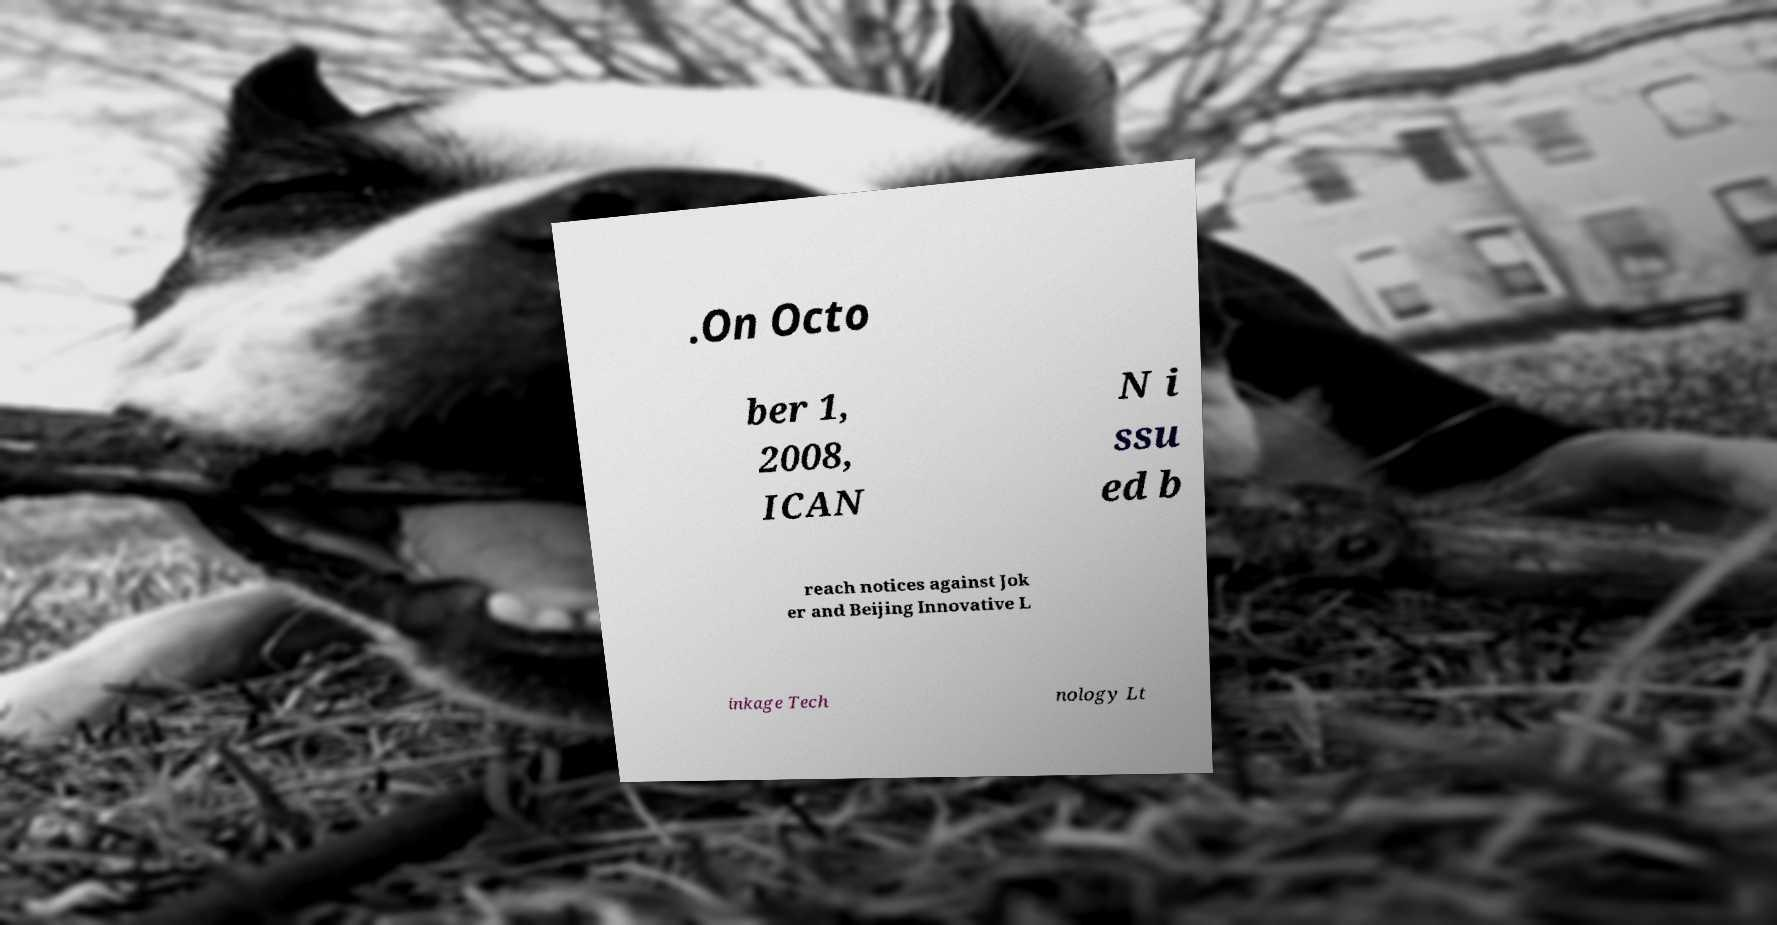Please read and relay the text visible in this image. What does it say? .On Octo ber 1, 2008, ICAN N i ssu ed b reach notices against Jok er and Beijing Innovative L inkage Tech nology Lt 